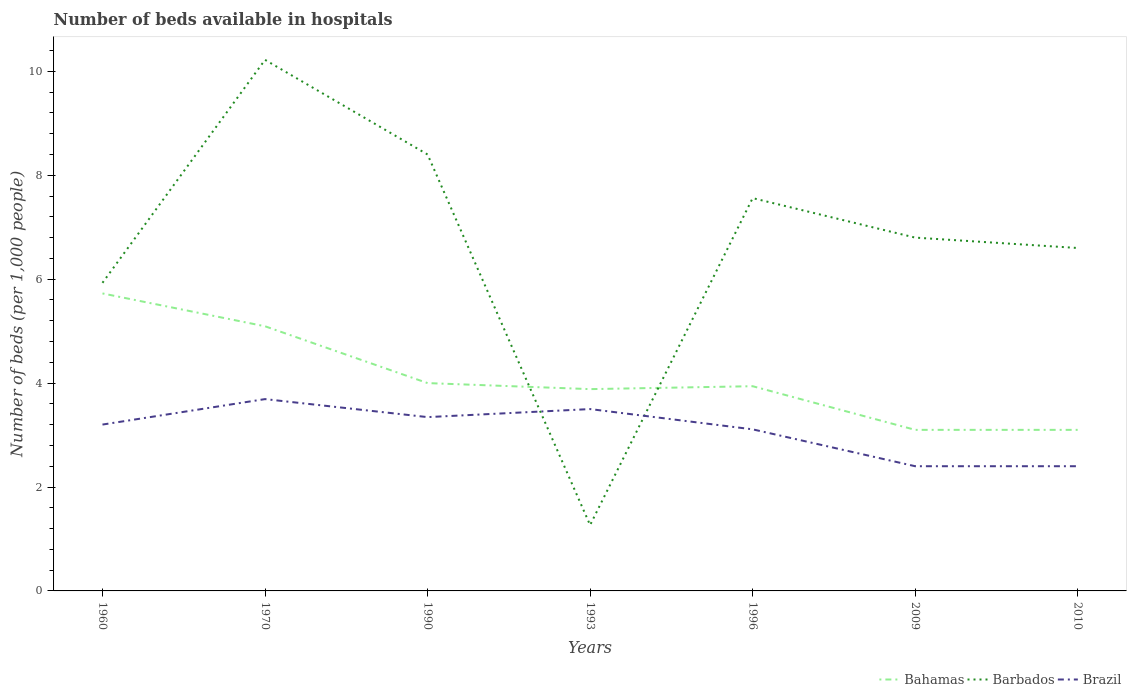How many different coloured lines are there?
Your answer should be compact. 3. Does the line corresponding to Bahamas intersect with the line corresponding to Brazil?
Offer a terse response. No. What is the total number of beds in the hospiatls of in Bahamas in the graph?
Provide a short and direct response. 1.84. What is the difference between the highest and the second highest number of beds in the hospiatls of in Bahamas?
Ensure brevity in your answer.  2.63. What is the difference between the highest and the lowest number of beds in the hospiatls of in Brazil?
Provide a short and direct response. 5. How many lines are there?
Make the answer very short. 3. How many years are there in the graph?
Your response must be concise. 7. What is the difference between two consecutive major ticks on the Y-axis?
Your answer should be compact. 2. Are the values on the major ticks of Y-axis written in scientific E-notation?
Your answer should be very brief. No. Does the graph contain any zero values?
Provide a short and direct response. No. Where does the legend appear in the graph?
Your answer should be very brief. Bottom right. How many legend labels are there?
Provide a succinct answer. 3. What is the title of the graph?
Give a very brief answer. Number of beds available in hospitals. What is the label or title of the Y-axis?
Ensure brevity in your answer.  Number of beds (per 1,0 people). What is the Number of beds (per 1,000 people) of Bahamas in 1960?
Offer a very short reply. 5.73. What is the Number of beds (per 1,000 people) of Barbados in 1960?
Offer a very short reply. 5.93. What is the Number of beds (per 1,000 people) of Brazil in 1960?
Make the answer very short. 3.2. What is the Number of beds (per 1,000 people) of Bahamas in 1970?
Provide a short and direct response. 5.09. What is the Number of beds (per 1,000 people) of Barbados in 1970?
Your answer should be compact. 10.22. What is the Number of beds (per 1,000 people) in Brazil in 1970?
Keep it short and to the point. 3.69. What is the Number of beds (per 1,000 people) in Barbados in 1990?
Offer a very short reply. 8.4. What is the Number of beds (per 1,000 people) in Brazil in 1990?
Keep it short and to the point. 3.35. What is the Number of beds (per 1,000 people) of Bahamas in 1993?
Make the answer very short. 3.88. What is the Number of beds (per 1,000 people) of Barbados in 1993?
Provide a short and direct response. 1.27. What is the Number of beds (per 1,000 people) of Brazil in 1993?
Provide a short and direct response. 3.5. What is the Number of beds (per 1,000 people) in Bahamas in 1996?
Your response must be concise. 3.94. What is the Number of beds (per 1,000 people) of Barbados in 1996?
Your answer should be compact. 7.56. What is the Number of beds (per 1,000 people) of Brazil in 1996?
Provide a succinct answer. 3.11. What is the Number of beds (per 1,000 people) of Bahamas in 2009?
Ensure brevity in your answer.  3.1. What is the Number of beds (per 1,000 people) in Barbados in 2010?
Ensure brevity in your answer.  6.6. Across all years, what is the maximum Number of beds (per 1,000 people) in Bahamas?
Provide a succinct answer. 5.73. Across all years, what is the maximum Number of beds (per 1,000 people) of Barbados?
Your answer should be very brief. 10.22. Across all years, what is the maximum Number of beds (per 1,000 people) of Brazil?
Keep it short and to the point. 3.69. Across all years, what is the minimum Number of beds (per 1,000 people) in Barbados?
Provide a short and direct response. 1.27. What is the total Number of beds (per 1,000 people) in Bahamas in the graph?
Your answer should be compact. 28.84. What is the total Number of beds (per 1,000 people) in Barbados in the graph?
Give a very brief answer. 46.78. What is the total Number of beds (per 1,000 people) of Brazil in the graph?
Give a very brief answer. 21.65. What is the difference between the Number of beds (per 1,000 people) in Bahamas in 1960 and that in 1970?
Keep it short and to the point. 0.63. What is the difference between the Number of beds (per 1,000 people) of Barbados in 1960 and that in 1970?
Give a very brief answer. -4.29. What is the difference between the Number of beds (per 1,000 people) of Brazil in 1960 and that in 1970?
Make the answer very short. -0.49. What is the difference between the Number of beds (per 1,000 people) in Bahamas in 1960 and that in 1990?
Ensure brevity in your answer.  1.73. What is the difference between the Number of beds (per 1,000 people) of Barbados in 1960 and that in 1990?
Your answer should be compact. -2.47. What is the difference between the Number of beds (per 1,000 people) of Brazil in 1960 and that in 1990?
Make the answer very short. -0.14. What is the difference between the Number of beds (per 1,000 people) of Bahamas in 1960 and that in 1993?
Offer a very short reply. 1.84. What is the difference between the Number of beds (per 1,000 people) in Barbados in 1960 and that in 1993?
Offer a terse response. 4.66. What is the difference between the Number of beds (per 1,000 people) of Brazil in 1960 and that in 1993?
Keep it short and to the point. -0.3. What is the difference between the Number of beds (per 1,000 people) in Bahamas in 1960 and that in 1996?
Your answer should be compact. 1.79. What is the difference between the Number of beds (per 1,000 people) of Barbados in 1960 and that in 1996?
Provide a short and direct response. -1.63. What is the difference between the Number of beds (per 1,000 people) in Brazil in 1960 and that in 1996?
Keep it short and to the point. 0.09. What is the difference between the Number of beds (per 1,000 people) in Bahamas in 1960 and that in 2009?
Keep it short and to the point. 2.63. What is the difference between the Number of beds (per 1,000 people) of Barbados in 1960 and that in 2009?
Give a very brief answer. -0.87. What is the difference between the Number of beds (per 1,000 people) of Brazil in 1960 and that in 2009?
Make the answer very short. 0.8. What is the difference between the Number of beds (per 1,000 people) in Bahamas in 1960 and that in 2010?
Offer a terse response. 2.63. What is the difference between the Number of beds (per 1,000 people) in Barbados in 1960 and that in 2010?
Offer a terse response. -0.67. What is the difference between the Number of beds (per 1,000 people) of Brazil in 1960 and that in 2010?
Keep it short and to the point. 0.8. What is the difference between the Number of beds (per 1,000 people) of Bahamas in 1970 and that in 1990?
Give a very brief answer. 1.09. What is the difference between the Number of beds (per 1,000 people) in Barbados in 1970 and that in 1990?
Keep it short and to the point. 1.82. What is the difference between the Number of beds (per 1,000 people) of Brazil in 1970 and that in 1990?
Provide a short and direct response. 0.35. What is the difference between the Number of beds (per 1,000 people) in Bahamas in 1970 and that in 1993?
Provide a succinct answer. 1.21. What is the difference between the Number of beds (per 1,000 people) in Barbados in 1970 and that in 1993?
Provide a succinct answer. 8.95. What is the difference between the Number of beds (per 1,000 people) in Brazil in 1970 and that in 1993?
Your response must be concise. 0.19. What is the difference between the Number of beds (per 1,000 people) in Bahamas in 1970 and that in 1996?
Your response must be concise. 1.15. What is the difference between the Number of beds (per 1,000 people) of Barbados in 1970 and that in 1996?
Give a very brief answer. 2.66. What is the difference between the Number of beds (per 1,000 people) of Brazil in 1970 and that in 1996?
Keep it short and to the point. 0.58. What is the difference between the Number of beds (per 1,000 people) in Bahamas in 1970 and that in 2009?
Provide a short and direct response. 1.99. What is the difference between the Number of beds (per 1,000 people) of Barbados in 1970 and that in 2009?
Give a very brief answer. 3.42. What is the difference between the Number of beds (per 1,000 people) of Brazil in 1970 and that in 2009?
Keep it short and to the point. 1.29. What is the difference between the Number of beds (per 1,000 people) in Bahamas in 1970 and that in 2010?
Offer a very short reply. 1.99. What is the difference between the Number of beds (per 1,000 people) of Barbados in 1970 and that in 2010?
Offer a very short reply. 3.62. What is the difference between the Number of beds (per 1,000 people) of Brazil in 1970 and that in 2010?
Offer a very short reply. 1.29. What is the difference between the Number of beds (per 1,000 people) in Bahamas in 1990 and that in 1993?
Make the answer very short. 0.12. What is the difference between the Number of beds (per 1,000 people) in Barbados in 1990 and that in 1993?
Provide a short and direct response. 7.13. What is the difference between the Number of beds (per 1,000 people) in Brazil in 1990 and that in 1993?
Your response must be concise. -0.15. What is the difference between the Number of beds (per 1,000 people) in Bahamas in 1990 and that in 1996?
Keep it short and to the point. 0.06. What is the difference between the Number of beds (per 1,000 people) in Barbados in 1990 and that in 1996?
Your answer should be very brief. 0.84. What is the difference between the Number of beds (per 1,000 people) in Brazil in 1990 and that in 1996?
Your response must be concise. 0.24. What is the difference between the Number of beds (per 1,000 people) in Bahamas in 1990 and that in 2009?
Offer a terse response. 0.9. What is the difference between the Number of beds (per 1,000 people) of Brazil in 1990 and that in 2009?
Offer a very short reply. 0.95. What is the difference between the Number of beds (per 1,000 people) in Barbados in 1990 and that in 2010?
Your answer should be very brief. 1.8. What is the difference between the Number of beds (per 1,000 people) in Brazil in 1990 and that in 2010?
Give a very brief answer. 0.95. What is the difference between the Number of beds (per 1,000 people) of Bahamas in 1993 and that in 1996?
Your answer should be compact. -0.06. What is the difference between the Number of beds (per 1,000 people) in Barbados in 1993 and that in 1996?
Ensure brevity in your answer.  -6.29. What is the difference between the Number of beds (per 1,000 people) in Brazil in 1993 and that in 1996?
Ensure brevity in your answer.  0.39. What is the difference between the Number of beds (per 1,000 people) in Bahamas in 1993 and that in 2009?
Offer a very short reply. 0.78. What is the difference between the Number of beds (per 1,000 people) of Barbados in 1993 and that in 2009?
Give a very brief answer. -5.53. What is the difference between the Number of beds (per 1,000 people) in Brazil in 1993 and that in 2009?
Keep it short and to the point. 1.1. What is the difference between the Number of beds (per 1,000 people) in Bahamas in 1993 and that in 2010?
Provide a short and direct response. 0.78. What is the difference between the Number of beds (per 1,000 people) in Barbados in 1993 and that in 2010?
Your response must be concise. -5.33. What is the difference between the Number of beds (per 1,000 people) of Brazil in 1993 and that in 2010?
Your response must be concise. 1.1. What is the difference between the Number of beds (per 1,000 people) in Bahamas in 1996 and that in 2009?
Your answer should be very brief. 0.84. What is the difference between the Number of beds (per 1,000 people) in Barbados in 1996 and that in 2009?
Offer a very short reply. 0.76. What is the difference between the Number of beds (per 1,000 people) in Brazil in 1996 and that in 2009?
Offer a terse response. 0.71. What is the difference between the Number of beds (per 1,000 people) of Bahamas in 1996 and that in 2010?
Keep it short and to the point. 0.84. What is the difference between the Number of beds (per 1,000 people) of Barbados in 1996 and that in 2010?
Offer a very short reply. 0.96. What is the difference between the Number of beds (per 1,000 people) of Brazil in 1996 and that in 2010?
Provide a succinct answer. 0.71. What is the difference between the Number of beds (per 1,000 people) of Bahamas in 1960 and the Number of beds (per 1,000 people) of Barbados in 1970?
Make the answer very short. -4.5. What is the difference between the Number of beds (per 1,000 people) of Bahamas in 1960 and the Number of beds (per 1,000 people) of Brazil in 1970?
Provide a succinct answer. 2.03. What is the difference between the Number of beds (per 1,000 people) in Barbados in 1960 and the Number of beds (per 1,000 people) in Brazil in 1970?
Ensure brevity in your answer.  2.24. What is the difference between the Number of beds (per 1,000 people) of Bahamas in 1960 and the Number of beds (per 1,000 people) of Barbados in 1990?
Your response must be concise. -2.67. What is the difference between the Number of beds (per 1,000 people) of Bahamas in 1960 and the Number of beds (per 1,000 people) of Brazil in 1990?
Provide a short and direct response. 2.38. What is the difference between the Number of beds (per 1,000 people) of Barbados in 1960 and the Number of beds (per 1,000 people) of Brazil in 1990?
Your answer should be compact. 2.58. What is the difference between the Number of beds (per 1,000 people) in Bahamas in 1960 and the Number of beds (per 1,000 people) in Barbados in 1993?
Your answer should be compact. 4.46. What is the difference between the Number of beds (per 1,000 people) of Bahamas in 1960 and the Number of beds (per 1,000 people) of Brazil in 1993?
Offer a very short reply. 2.23. What is the difference between the Number of beds (per 1,000 people) in Barbados in 1960 and the Number of beds (per 1,000 people) in Brazil in 1993?
Your answer should be compact. 2.43. What is the difference between the Number of beds (per 1,000 people) of Bahamas in 1960 and the Number of beds (per 1,000 people) of Barbados in 1996?
Your answer should be very brief. -1.83. What is the difference between the Number of beds (per 1,000 people) of Bahamas in 1960 and the Number of beds (per 1,000 people) of Brazil in 1996?
Provide a short and direct response. 2.62. What is the difference between the Number of beds (per 1,000 people) in Barbados in 1960 and the Number of beds (per 1,000 people) in Brazil in 1996?
Provide a short and direct response. 2.82. What is the difference between the Number of beds (per 1,000 people) of Bahamas in 1960 and the Number of beds (per 1,000 people) of Barbados in 2009?
Your answer should be compact. -1.07. What is the difference between the Number of beds (per 1,000 people) of Bahamas in 1960 and the Number of beds (per 1,000 people) of Brazil in 2009?
Keep it short and to the point. 3.33. What is the difference between the Number of beds (per 1,000 people) in Barbados in 1960 and the Number of beds (per 1,000 people) in Brazil in 2009?
Provide a short and direct response. 3.53. What is the difference between the Number of beds (per 1,000 people) of Bahamas in 1960 and the Number of beds (per 1,000 people) of Barbados in 2010?
Ensure brevity in your answer.  -0.87. What is the difference between the Number of beds (per 1,000 people) of Bahamas in 1960 and the Number of beds (per 1,000 people) of Brazil in 2010?
Your answer should be very brief. 3.33. What is the difference between the Number of beds (per 1,000 people) in Barbados in 1960 and the Number of beds (per 1,000 people) in Brazil in 2010?
Offer a very short reply. 3.53. What is the difference between the Number of beds (per 1,000 people) in Bahamas in 1970 and the Number of beds (per 1,000 people) in Barbados in 1990?
Provide a short and direct response. -3.31. What is the difference between the Number of beds (per 1,000 people) of Bahamas in 1970 and the Number of beds (per 1,000 people) of Brazil in 1990?
Your response must be concise. 1.75. What is the difference between the Number of beds (per 1,000 people) in Barbados in 1970 and the Number of beds (per 1,000 people) in Brazil in 1990?
Make the answer very short. 6.88. What is the difference between the Number of beds (per 1,000 people) in Bahamas in 1970 and the Number of beds (per 1,000 people) in Barbados in 1993?
Keep it short and to the point. 3.83. What is the difference between the Number of beds (per 1,000 people) of Bahamas in 1970 and the Number of beds (per 1,000 people) of Brazil in 1993?
Keep it short and to the point. 1.59. What is the difference between the Number of beds (per 1,000 people) in Barbados in 1970 and the Number of beds (per 1,000 people) in Brazil in 1993?
Keep it short and to the point. 6.72. What is the difference between the Number of beds (per 1,000 people) in Bahamas in 1970 and the Number of beds (per 1,000 people) in Barbados in 1996?
Provide a short and direct response. -2.47. What is the difference between the Number of beds (per 1,000 people) of Bahamas in 1970 and the Number of beds (per 1,000 people) of Brazil in 1996?
Your answer should be very brief. 1.98. What is the difference between the Number of beds (per 1,000 people) of Barbados in 1970 and the Number of beds (per 1,000 people) of Brazil in 1996?
Make the answer very short. 7.11. What is the difference between the Number of beds (per 1,000 people) of Bahamas in 1970 and the Number of beds (per 1,000 people) of Barbados in 2009?
Your response must be concise. -1.71. What is the difference between the Number of beds (per 1,000 people) in Bahamas in 1970 and the Number of beds (per 1,000 people) in Brazil in 2009?
Ensure brevity in your answer.  2.69. What is the difference between the Number of beds (per 1,000 people) of Barbados in 1970 and the Number of beds (per 1,000 people) of Brazil in 2009?
Make the answer very short. 7.82. What is the difference between the Number of beds (per 1,000 people) of Bahamas in 1970 and the Number of beds (per 1,000 people) of Barbados in 2010?
Ensure brevity in your answer.  -1.51. What is the difference between the Number of beds (per 1,000 people) in Bahamas in 1970 and the Number of beds (per 1,000 people) in Brazil in 2010?
Offer a terse response. 2.69. What is the difference between the Number of beds (per 1,000 people) of Barbados in 1970 and the Number of beds (per 1,000 people) of Brazil in 2010?
Your answer should be very brief. 7.82. What is the difference between the Number of beds (per 1,000 people) of Bahamas in 1990 and the Number of beds (per 1,000 people) of Barbados in 1993?
Provide a short and direct response. 2.73. What is the difference between the Number of beds (per 1,000 people) in Barbados in 1990 and the Number of beds (per 1,000 people) in Brazil in 1993?
Make the answer very short. 4.9. What is the difference between the Number of beds (per 1,000 people) in Bahamas in 1990 and the Number of beds (per 1,000 people) in Barbados in 1996?
Give a very brief answer. -3.56. What is the difference between the Number of beds (per 1,000 people) of Bahamas in 1990 and the Number of beds (per 1,000 people) of Brazil in 1996?
Your answer should be very brief. 0.89. What is the difference between the Number of beds (per 1,000 people) in Barbados in 1990 and the Number of beds (per 1,000 people) in Brazil in 1996?
Provide a succinct answer. 5.29. What is the difference between the Number of beds (per 1,000 people) in Bahamas in 1990 and the Number of beds (per 1,000 people) in Barbados in 2009?
Ensure brevity in your answer.  -2.8. What is the difference between the Number of beds (per 1,000 people) in Barbados in 1990 and the Number of beds (per 1,000 people) in Brazil in 2009?
Ensure brevity in your answer.  6. What is the difference between the Number of beds (per 1,000 people) of Bahamas in 1990 and the Number of beds (per 1,000 people) of Barbados in 2010?
Provide a short and direct response. -2.6. What is the difference between the Number of beds (per 1,000 people) in Bahamas in 1990 and the Number of beds (per 1,000 people) in Brazil in 2010?
Your answer should be compact. 1.6. What is the difference between the Number of beds (per 1,000 people) in Bahamas in 1993 and the Number of beds (per 1,000 people) in Barbados in 1996?
Give a very brief answer. -3.68. What is the difference between the Number of beds (per 1,000 people) of Bahamas in 1993 and the Number of beds (per 1,000 people) of Brazil in 1996?
Your response must be concise. 0.77. What is the difference between the Number of beds (per 1,000 people) of Barbados in 1993 and the Number of beds (per 1,000 people) of Brazil in 1996?
Make the answer very short. -1.84. What is the difference between the Number of beds (per 1,000 people) in Bahamas in 1993 and the Number of beds (per 1,000 people) in Barbados in 2009?
Give a very brief answer. -2.92. What is the difference between the Number of beds (per 1,000 people) in Bahamas in 1993 and the Number of beds (per 1,000 people) in Brazil in 2009?
Give a very brief answer. 1.48. What is the difference between the Number of beds (per 1,000 people) of Barbados in 1993 and the Number of beds (per 1,000 people) of Brazil in 2009?
Your answer should be compact. -1.13. What is the difference between the Number of beds (per 1,000 people) of Bahamas in 1993 and the Number of beds (per 1,000 people) of Barbados in 2010?
Make the answer very short. -2.72. What is the difference between the Number of beds (per 1,000 people) in Bahamas in 1993 and the Number of beds (per 1,000 people) in Brazil in 2010?
Give a very brief answer. 1.48. What is the difference between the Number of beds (per 1,000 people) in Barbados in 1993 and the Number of beds (per 1,000 people) in Brazil in 2010?
Make the answer very short. -1.13. What is the difference between the Number of beds (per 1,000 people) of Bahamas in 1996 and the Number of beds (per 1,000 people) of Barbados in 2009?
Provide a succinct answer. -2.86. What is the difference between the Number of beds (per 1,000 people) in Bahamas in 1996 and the Number of beds (per 1,000 people) in Brazil in 2009?
Your answer should be very brief. 1.54. What is the difference between the Number of beds (per 1,000 people) in Barbados in 1996 and the Number of beds (per 1,000 people) in Brazil in 2009?
Your answer should be very brief. 5.16. What is the difference between the Number of beds (per 1,000 people) of Bahamas in 1996 and the Number of beds (per 1,000 people) of Barbados in 2010?
Offer a very short reply. -2.66. What is the difference between the Number of beds (per 1,000 people) of Bahamas in 1996 and the Number of beds (per 1,000 people) of Brazil in 2010?
Offer a very short reply. 1.54. What is the difference between the Number of beds (per 1,000 people) in Barbados in 1996 and the Number of beds (per 1,000 people) in Brazil in 2010?
Your answer should be very brief. 5.16. What is the difference between the Number of beds (per 1,000 people) of Barbados in 2009 and the Number of beds (per 1,000 people) of Brazil in 2010?
Offer a very short reply. 4.4. What is the average Number of beds (per 1,000 people) in Bahamas per year?
Provide a short and direct response. 4.12. What is the average Number of beds (per 1,000 people) in Barbados per year?
Provide a short and direct response. 6.68. What is the average Number of beds (per 1,000 people) in Brazil per year?
Provide a succinct answer. 3.09. In the year 1960, what is the difference between the Number of beds (per 1,000 people) of Bahamas and Number of beds (per 1,000 people) of Barbados?
Provide a short and direct response. -0.2. In the year 1960, what is the difference between the Number of beds (per 1,000 people) in Bahamas and Number of beds (per 1,000 people) in Brazil?
Provide a succinct answer. 2.52. In the year 1960, what is the difference between the Number of beds (per 1,000 people) of Barbados and Number of beds (per 1,000 people) of Brazil?
Your answer should be compact. 2.73. In the year 1970, what is the difference between the Number of beds (per 1,000 people) in Bahamas and Number of beds (per 1,000 people) in Barbados?
Offer a terse response. -5.13. In the year 1970, what is the difference between the Number of beds (per 1,000 people) in Bahamas and Number of beds (per 1,000 people) in Brazil?
Make the answer very short. 1.4. In the year 1970, what is the difference between the Number of beds (per 1,000 people) of Barbados and Number of beds (per 1,000 people) of Brazil?
Provide a short and direct response. 6.53. In the year 1990, what is the difference between the Number of beds (per 1,000 people) in Bahamas and Number of beds (per 1,000 people) in Barbados?
Your answer should be compact. -4.4. In the year 1990, what is the difference between the Number of beds (per 1,000 people) in Bahamas and Number of beds (per 1,000 people) in Brazil?
Ensure brevity in your answer.  0.65. In the year 1990, what is the difference between the Number of beds (per 1,000 people) in Barbados and Number of beds (per 1,000 people) in Brazil?
Keep it short and to the point. 5.05. In the year 1993, what is the difference between the Number of beds (per 1,000 people) of Bahamas and Number of beds (per 1,000 people) of Barbados?
Ensure brevity in your answer.  2.62. In the year 1993, what is the difference between the Number of beds (per 1,000 people) of Bahamas and Number of beds (per 1,000 people) of Brazil?
Give a very brief answer. 0.38. In the year 1993, what is the difference between the Number of beds (per 1,000 people) of Barbados and Number of beds (per 1,000 people) of Brazil?
Offer a very short reply. -2.23. In the year 1996, what is the difference between the Number of beds (per 1,000 people) of Bahamas and Number of beds (per 1,000 people) of Barbados?
Offer a very short reply. -3.62. In the year 1996, what is the difference between the Number of beds (per 1,000 people) in Bahamas and Number of beds (per 1,000 people) in Brazil?
Your answer should be compact. 0.83. In the year 1996, what is the difference between the Number of beds (per 1,000 people) of Barbados and Number of beds (per 1,000 people) of Brazil?
Your answer should be compact. 4.45. In the year 2009, what is the difference between the Number of beds (per 1,000 people) in Bahamas and Number of beds (per 1,000 people) in Barbados?
Offer a terse response. -3.7. In the year 2009, what is the difference between the Number of beds (per 1,000 people) of Bahamas and Number of beds (per 1,000 people) of Brazil?
Give a very brief answer. 0.7. In the year 2010, what is the difference between the Number of beds (per 1,000 people) in Bahamas and Number of beds (per 1,000 people) in Barbados?
Provide a succinct answer. -3.5. In the year 2010, what is the difference between the Number of beds (per 1,000 people) of Bahamas and Number of beds (per 1,000 people) of Brazil?
Give a very brief answer. 0.7. What is the ratio of the Number of beds (per 1,000 people) of Bahamas in 1960 to that in 1970?
Provide a succinct answer. 1.12. What is the ratio of the Number of beds (per 1,000 people) of Barbados in 1960 to that in 1970?
Provide a short and direct response. 0.58. What is the ratio of the Number of beds (per 1,000 people) in Brazil in 1960 to that in 1970?
Your response must be concise. 0.87. What is the ratio of the Number of beds (per 1,000 people) in Bahamas in 1960 to that in 1990?
Your answer should be very brief. 1.43. What is the ratio of the Number of beds (per 1,000 people) in Barbados in 1960 to that in 1990?
Provide a succinct answer. 0.71. What is the ratio of the Number of beds (per 1,000 people) in Brazil in 1960 to that in 1990?
Your response must be concise. 0.96. What is the ratio of the Number of beds (per 1,000 people) in Bahamas in 1960 to that in 1993?
Your response must be concise. 1.47. What is the ratio of the Number of beds (per 1,000 people) of Barbados in 1960 to that in 1993?
Offer a very short reply. 4.68. What is the ratio of the Number of beds (per 1,000 people) in Brazil in 1960 to that in 1993?
Your answer should be compact. 0.91. What is the ratio of the Number of beds (per 1,000 people) of Bahamas in 1960 to that in 1996?
Provide a short and direct response. 1.45. What is the ratio of the Number of beds (per 1,000 people) in Barbados in 1960 to that in 1996?
Provide a short and direct response. 0.78. What is the ratio of the Number of beds (per 1,000 people) in Brazil in 1960 to that in 1996?
Provide a succinct answer. 1.03. What is the ratio of the Number of beds (per 1,000 people) in Bahamas in 1960 to that in 2009?
Make the answer very short. 1.85. What is the ratio of the Number of beds (per 1,000 people) in Barbados in 1960 to that in 2009?
Provide a succinct answer. 0.87. What is the ratio of the Number of beds (per 1,000 people) in Brazil in 1960 to that in 2009?
Make the answer very short. 1.33. What is the ratio of the Number of beds (per 1,000 people) in Bahamas in 1960 to that in 2010?
Provide a succinct answer. 1.85. What is the ratio of the Number of beds (per 1,000 people) of Barbados in 1960 to that in 2010?
Offer a terse response. 0.9. What is the ratio of the Number of beds (per 1,000 people) of Brazil in 1960 to that in 2010?
Your answer should be very brief. 1.33. What is the ratio of the Number of beds (per 1,000 people) in Bahamas in 1970 to that in 1990?
Your response must be concise. 1.27. What is the ratio of the Number of beds (per 1,000 people) of Barbados in 1970 to that in 1990?
Provide a succinct answer. 1.22. What is the ratio of the Number of beds (per 1,000 people) of Brazil in 1970 to that in 1990?
Provide a succinct answer. 1.1. What is the ratio of the Number of beds (per 1,000 people) in Bahamas in 1970 to that in 1993?
Give a very brief answer. 1.31. What is the ratio of the Number of beds (per 1,000 people) in Barbados in 1970 to that in 1993?
Your answer should be compact. 8.06. What is the ratio of the Number of beds (per 1,000 people) in Brazil in 1970 to that in 1993?
Keep it short and to the point. 1.05. What is the ratio of the Number of beds (per 1,000 people) of Bahamas in 1970 to that in 1996?
Make the answer very short. 1.29. What is the ratio of the Number of beds (per 1,000 people) of Barbados in 1970 to that in 1996?
Offer a terse response. 1.35. What is the ratio of the Number of beds (per 1,000 people) of Brazil in 1970 to that in 1996?
Make the answer very short. 1.19. What is the ratio of the Number of beds (per 1,000 people) in Bahamas in 1970 to that in 2009?
Your answer should be very brief. 1.64. What is the ratio of the Number of beds (per 1,000 people) of Barbados in 1970 to that in 2009?
Offer a terse response. 1.5. What is the ratio of the Number of beds (per 1,000 people) in Brazil in 1970 to that in 2009?
Your answer should be very brief. 1.54. What is the ratio of the Number of beds (per 1,000 people) in Bahamas in 1970 to that in 2010?
Provide a short and direct response. 1.64. What is the ratio of the Number of beds (per 1,000 people) of Barbados in 1970 to that in 2010?
Provide a succinct answer. 1.55. What is the ratio of the Number of beds (per 1,000 people) in Brazil in 1970 to that in 2010?
Provide a succinct answer. 1.54. What is the ratio of the Number of beds (per 1,000 people) in Bahamas in 1990 to that in 1993?
Make the answer very short. 1.03. What is the ratio of the Number of beds (per 1,000 people) of Barbados in 1990 to that in 1993?
Your answer should be very brief. 6.63. What is the ratio of the Number of beds (per 1,000 people) in Brazil in 1990 to that in 1993?
Offer a terse response. 0.96. What is the ratio of the Number of beds (per 1,000 people) in Bahamas in 1990 to that in 1996?
Your answer should be compact. 1.02. What is the ratio of the Number of beds (per 1,000 people) in Brazil in 1990 to that in 1996?
Make the answer very short. 1.08. What is the ratio of the Number of beds (per 1,000 people) in Bahamas in 1990 to that in 2009?
Provide a short and direct response. 1.29. What is the ratio of the Number of beds (per 1,000 people) of Barbados in 1990 to that in 2009?
Make the answer very short. 1.24. What is the ratio of the Number of beds (per 1,000 people) in Brazil in 1990 to that in 2009?
Make the answer very short. 1.39. What is the ratio of the Number of beds (per 1,000 people) of Bahamas in 1990 to that in 2010?
Your response must be concise. 1.29. What is the ratio of the Number of beds (per 1,000 people) in Barbados in 1990 to that in 2010?
Offer a very short reply. 1.27. What is the ratio of the Number of beds (per 1,000 people) in Brazil in 1990 to that in 2010?
Give a very brief answer. 1.39. What is the ratio of the Number of beds (per 1,000 people) of Bahamas in 1993 to that in 1996?
Your response must be concise. 0.99. What is the ratio of the Number of beds (per 1,000 people) in Barbados in 1993 to that in 1996?
Provide a succinct answer. 0.17. What is the ratio of the Number of beds (per 1,000 people) in Brazil in 1993 to that in 1996?
Make the answer very short. 1.13. What is the ratio of the Number of beds (per 1,000 people) of Bahamas in 1993 to that in 2009?
Offer a very short reply. 1.25. What is the ratio of the Number of beds (per 1,000 people) of Barbados in 1993 to that in 2009?
Make the answer very short. 0.19. What is the ratio of the Number of beds (per 1,000 people) in Brazil in 1993 to that in 2009?
Offer a terse response. 1.46. What is the ratio of the Number of beds (per 1,000 people) of Bahamas in 1993 to that in 2010?
Keep it short and to the point. 1.25. What is the ratio of the Number of beds (per 1,000 people) in Barbados in 1993 to that in 2010?
Make the answer very short. 0.19. What is the ratio of the Number of beds (per 1,000 people) in Brazil in 1993 to that in 2010?
Ensure brevity in your answer.  1.46. What is the ratio of the Number of beds (per 1,000 people) of Bahamas in 1996 to that in 2009?
Ensure brevity in your answer.  1.27. What is the ratio of the Number of beds (per 1,000 people) of Barbados in 1996 to that in 2009?
Provide a short and direct response. 1.11. What is the ratio of the Number of beds (per 1,000 people) in Brazil in 1996 to that in 2009?
Your answer should be compact. 1.3. What is the ratio of the Number of beds (per 1,000 people) of Bahamas in 1996 to that in 2010?
Keep it short and to the point. 1.27. What is the ratio of the Number of beds (per 1,000 people) in Barbados in 1996 to that in 2010?
Your response must be concise. 1.15. What is the ratio of the Number of beds (per 1,000 people) of Brazil in 1996 to that in 2010?
Give a very brief answer. 1.3. What is the ratio of the Number of beds (per 1,000 people) in Bahamas in 2009 to that in 2010?
Provide a succinct answer. 1. What is the ratio of the Number of beds (per 1,000 people) in Barbados in 2009 to that in 2010?
Your answer should be very brief. 1.03. What is the difference between the highest and the second highest Number of beds (per 1,000 people) of Bahamas?
Offer a very short reply. 0.63. What is the difference between the highest and the second highest Number of beds (per 1,000 people) in Barbados?
Give a very brief answer. 1.82. What is the difference between the highest and the second highest Number of beds (per 1,000 people) in Brazil?
Keep it short and to the point. 0.19. What is the difference between the highest and the lowest Number of beds (per 1,000 people) in Bahamas?
Offer a very short reply. 2.63. What is the difference between the highest and the lowest Number of beds (per 1,000 people) in Barbados?
Ensure brevity in your answer.  8.95. What is the difference between the highest and the lowest Number of beds (per 1,000 people) of Brazil?
Make the answer very short. 1.29. 